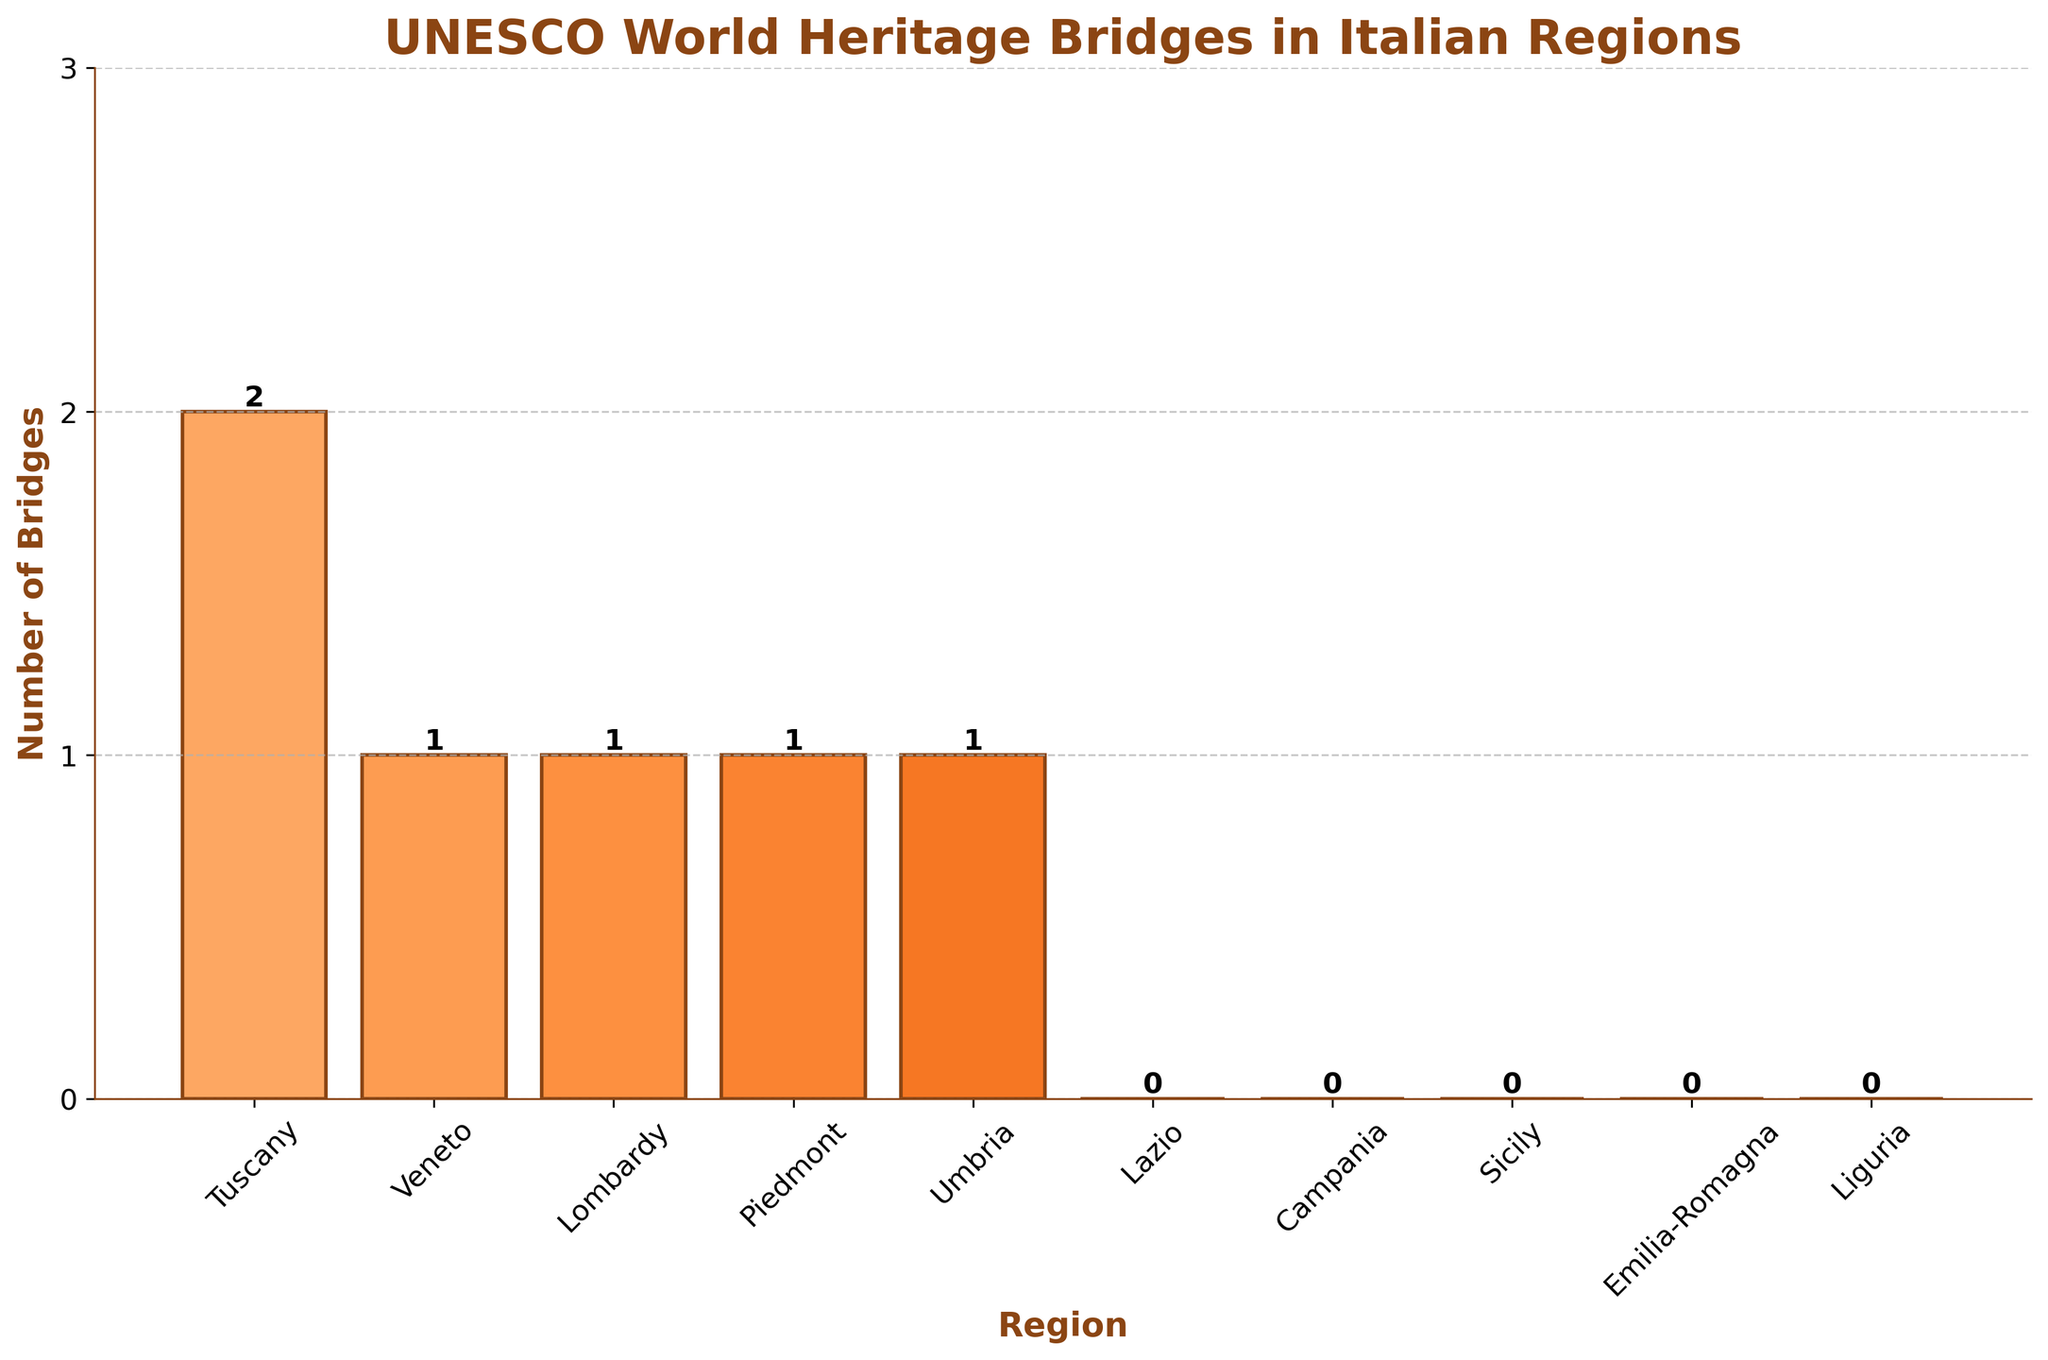Which region has the most UNESCO World Heritage Bridges? The highest bar represents Tuscany with two bridges, indicating it has the most UNESCO World Heritage bridges.
Answer: Tuscany What is the combined total of UNESCO World Heritage Bridges in regions that have at least one bridge? Tuscany has 2, Veneto has 1, Lombardy has 1, Piedmont has 1, and Umbria has 1. Summing these gives 2 + 1 + 1 + 1 + 1 = 6.
Answer: 6 How many regions have zero UNESCO World Heritage Bridges? According to the bars at height 0, Lazio, Campania, Sicily, Emilia-Romagna, and Liguria have zero bridges. There are 5 regions.
Answer: 5 Compare the number of UNESCO World Heritage Bridges in Tuscany and Veneto. Which has more and by how many? Tuscany has 2 bridges, and Veneto has 1 bridge. Tuscany has 1 more bridge than Veneto (2 - 1 = 1).
Answer: Tuscany by 1 How does the number of UNESCO World Heritage Bridges in Lombardy compare to the number in Piedmont? Both Lombardy and Piedmont have 1 bridge each; they are equal.
Answer: Equal Which regions have an equal number of UNESCO World Heritage Bridges? Lombardy, Veneto, Piedmont, and Umbria each have 1 bridge. Therefore, they all have an equal number of bridges.
Answer: Lombardy, Veneto, Piedmont, Umbria What is the visual color theme used for the bars representing the different regions? The bars are shaded in different tones of orange, with a palette fading from light to dark orange.
Answer: Shades of orange If you add one more bridge to each region that currently has at least one bridge, what will be the new total number of UNESCO World Heritage Bridges? Currently, Tuscany has 2, Veneto 1, Lombardy 1, Piedmont 1, and Umbria 1. Adding one to each gives 3 + 2 + 2 + 2 + 2 = 11.
Answer: 11 What can you say about the height difference between the tallest bar and the shortest bars that represent non-zero data points? The tallest bar (Tuscany, 2 bridges) is 1 unit higher than the shortest bars representing non-zero (1 bridge in Veneto, Lombardy, Piedmont, and Umbria).
Answer: 1 unit Visually, how does the number of UNESCO World Heritage Bridges in Lazio differ from that in Umbria? Lazio's bar is at 0 height, indicating no bridges, while the bar for Umbria is higher at 1 bridge.
Answer: Lazio has 0, Umbria has 1 